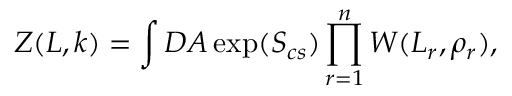Convert formula to latex. <formula><loc_0><loc_0><loc_500><loc_500>Z ( L , k ) = \int D A \exp ( S _ { c s } ) \prod _ { r = 1 } ^ { n } W ( L _ { r } , \rho _ { r } ) ,</formula> 